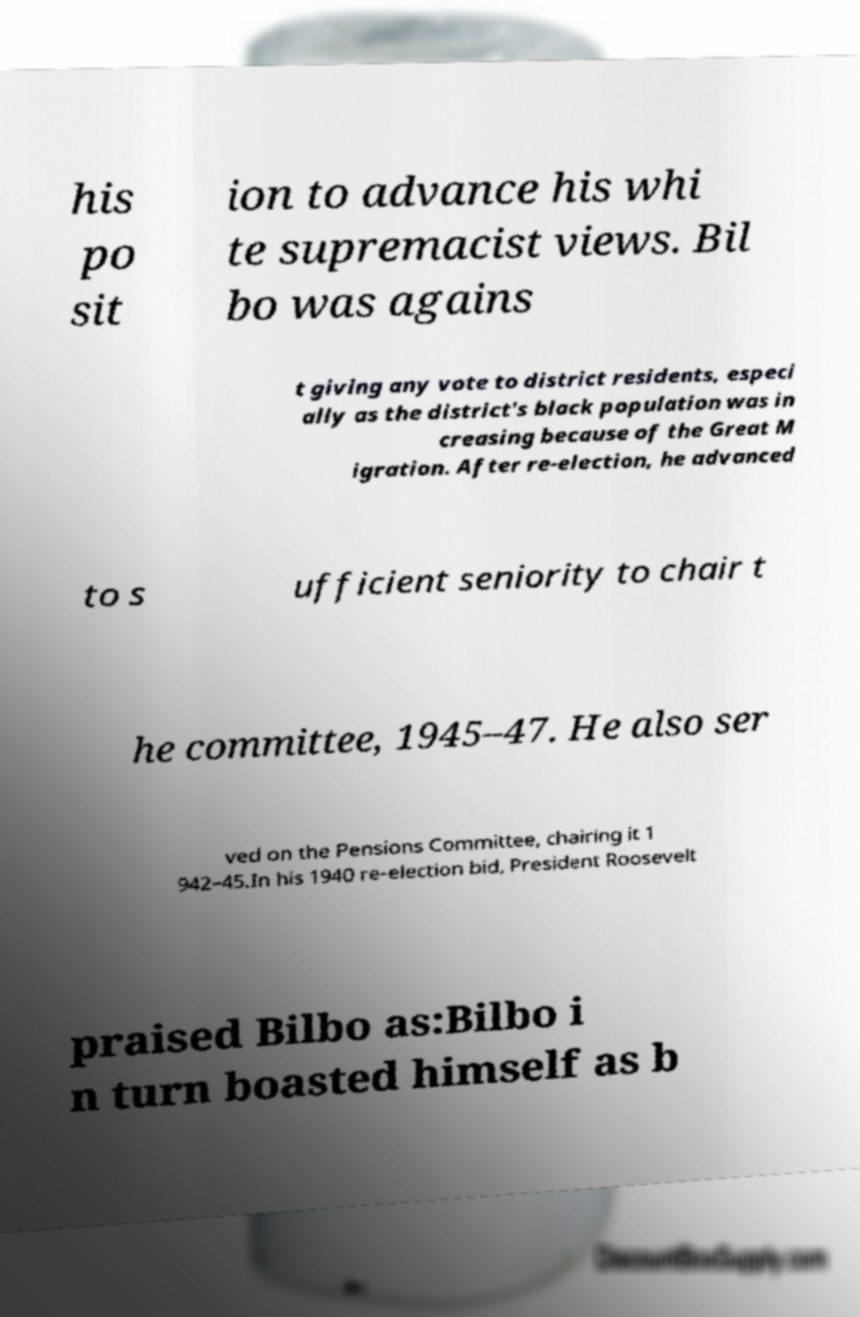For documentation purposes, I need the text within this image transcribed. Could you provide that? his po sit ion to advance his whi te supremacist views. Bil bo was agains t giving any vote to district residents, especi ally as the district's black population was in creasing because of the Great M igration. After re-election, he advanced to s ufficient seniority to chair t he committee, 1945–47. He also ser ved on the Pensions Committee, chairing it 1 942–45.In his 1940 re-election bid, President Roosevelt praised Bilbo as:Bilbo i n turn boasted himself as b 